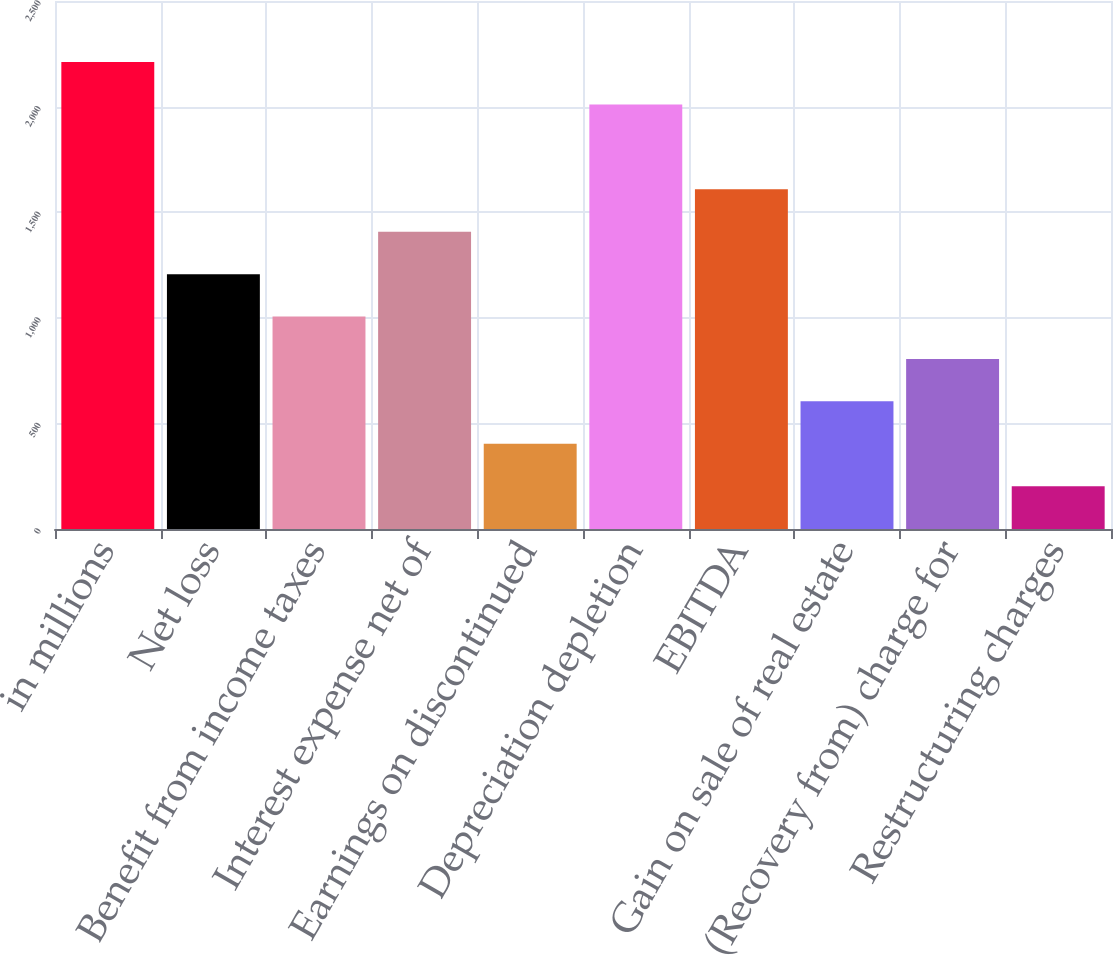<chart> <loc_0><loc_0><loc_500><loc_500><bar_chart><fcel>in millions<fcel>Net loss<fcel>Benefit from income taxes<fcel>Interest expense net of<fcel>Earnings on discontinued<fcel>Depreciation depletion<fcel>EBITDA<fcel>Gain on sale of real estate<fcel>(Recovery from) charge for<fcel>Restructuring charges<nl><fcel>2210.78<fcel>1206.78<fcel>1005.98<fcel>1407.58<fcel>403.58<fcel>2009.98<fcel>1608.38<fcel>604.38<fcel>805.18<fcel>202.78<nl></chart> 